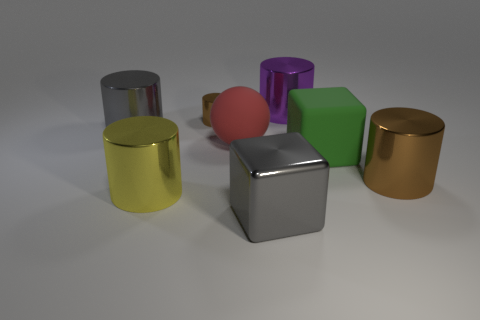Subtract all purple shiny cylinders. How many cylinders are left? 4 Subtract all purple cylinders. How many cylinders are left? 4 Subtract 2 cylinders. How many cylinders are left? 3 Subtract all green cylinders. Subtract all green blocks. How many cylinders are left? 5 Add 1 tiny yellow cylinders. How many objects exist? 9 Subtract all blocks. How many objects are left? 6 Subtract all metal cylinders. Subtract all green matte blocks. How many objects are left? 2 Add 2 big gray shiny things. How many big gray shiny things are left? 4 Add 5 small cylinders. How many small cylinders exist? 6 Subtract 0 purple blocks. How many objects are left? 8 